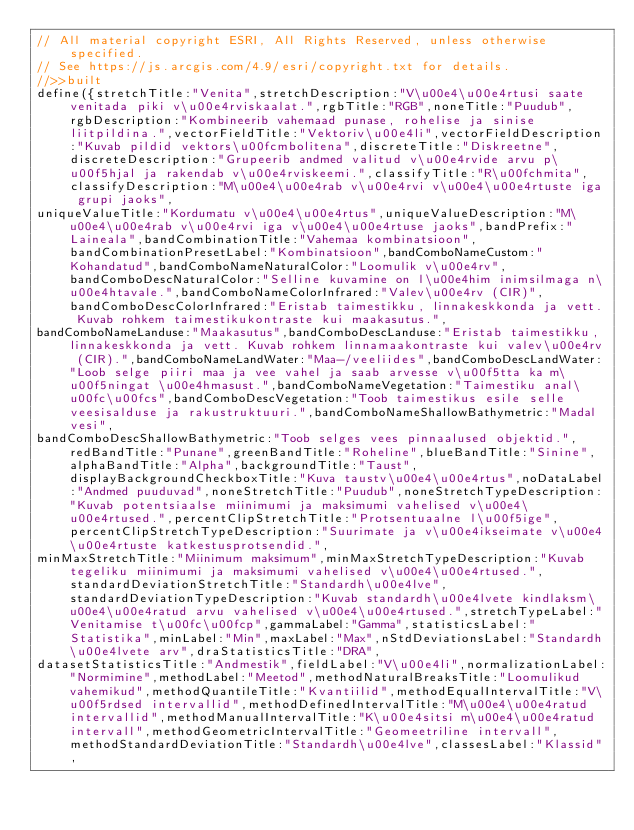Convert code to text. <code><loc_0><loc_0><loc_500><loc_500><_JavaScript_>// All material copyright ESRI, All Rights Reserved, unless otherwise specified.
// See https://js.arcgis.com/4.9/esri/copyright.txt for details.
//>>built
define({stretchTitle:"Venita",stretchDescription:"V\u00e4\u00e4rtusi saate venitada piki v\u00e4rviskaalat.",rgbTitle:"RGB",noneTitle:"Puudub",rgbDescription:"Kombineerib vahemaad punase, rohelise ja sinise liitpildina.",vectorFieldTitle:"Vektoriv\u00e4li",vectorFieldDescription:"Kuvab pildid vektors\u00fcmbolitena",discreteTitle:"Diskreetne",discreteDescription:"Grupeerib andmed valitud v\u00e4rvide arvu p\u00f5hjal ja rakendab v\u00e4rviskeemi.",classifyTitle:"R\u00fchmita",classifyDescription:"M\u00e4\u00e4rab v\u00e4rvi v\u00e4\u00e4rtuste iga grupi jaoks",
uniqueValueTitle:"Kordumatu v\u00e4\u00e4rtus",uniqueValueDescription:"M\u00e4\u00e4rab v\u00e4rvi iga v\u00e4\u00e4rtuse jaoks",bandPrefix:"Laineala",bandCombinationTitle:"Vahemaa kombinatsioon",bandCombinationPresetLabel:"Kombinatsioon",bandComboNameCustom:"Kohandatud",bandComboNameNaturalColor:"Loomulik v\u00e4rv",bandComboDescNaturalColor:"Selline kuvamine on l\u00e4him inimsilmaga n\u00e4htavale.",bandComboNameColorInfrared:"Valev\u00e4rv (CIR)",bandComboDescColorInfrared:"Eristab taimestikku, linnakeskkonda ja vett. Kuvab rohkem taimestikukontraste kui maakasutus.",
bandComboNameLanduse:"Maakasutus",bandComboDescLanduse:"Eristab taimestikku, linnakeskkonda ja vett. Kuvab rohkem linnamaakontraste kui valev\u00e4rv (CIR).",bandComboNameLandWater:"Maa-/veeliides",bandComboDescLandWater:"Loob selge piiri maa ja vee vahel ja saab arvesse v\u00f5tta ka m\u00f5ningat \u00e4hmasust.",bandComboNameVegetation:"Taimestiku anal\u00fc\u00fcs",bandComboDescVegetation:"Toob taimestikus esile selle veesisalduse ja rakustruktuuri.",bandComboNameShallowBathymetric:"Madal vesi",
bandComboDescShallowBathymetric:"Toob selges vees pinnaalused objektid.",redBandTitle:"Punane",greenBandTitle:"Roheline",blueBandTitle:"Sinine",alphaBandTitle:"Alpha",backgroundTitle:"Taust",displayBackgroundCheckboxTitle:"Kuva taustv\u00e4\u00e4rtus",noDataLabel:"Andmed puuduvad",noneStretchTitle:"Puudub",noneStretchTypeDescription:"Kuvab potentsiaalse miinimumi ja maksimumi vahelised v\u00e4\u00e4rtused.",percentClipStretchTitle:"Protsentuaalne l\u00f5ige",percentClipStretchTypeDescription:"Suurimate ja v\u00e4ikseimate v\u00e4\u00e4rtuste katkestusprotsendid.",
minMaxStretchTitle:"Miinimum maksimum",minMaxStretchTypeDescription:"Kuvab tegeliku miinimumi ja maksimumi vahelised v\u00e4\u00e4rtused.",standardDeviationStretchTitle:"Standardh\u00e4lve",standardDeviationTypeDescription:"Kuvab standardh\u00e4lvete kindlaksm\u00e4\u00e4ratud arvu vahelised v\u00e4\u00e4rtused.",stretchTypeLabel:"Venitamise t\u00fc\u00fcp",gammaLabel:"Gamma",statisticsLabel:"Statistika",minLabel:"Min",maxLabel:"Max",nStdDeviationsLabel:"Standardh\u00e4lvete arv",draStatisticsTitle:"DRA",
datasetStatisticsTitle:"Andmestik",fieldLabel:"V\u00e4li",normalizationLabel:"Normimine",methodLabel:"Meetod",methodNaturalBreaksTitle:"Loomulikud vahemikud",methodQuantileTitle:"Kvantiilid",methodEqualIntervalTitle:"V\u00f5rdsed intervallid",methodDefinedIntervalTitle:"M\u00e4\u00e4ratud intervallid",methodManualIntervalTitle:"K\u00e4sitsi m\u00e4\u00e4ratud intervall",methodGeometricIntervalTitle:"Geomeetriline intervall",methodStandardDeviationTitle:"Standardh\u00e4lve",classesLabel:"Klassid",</code> 